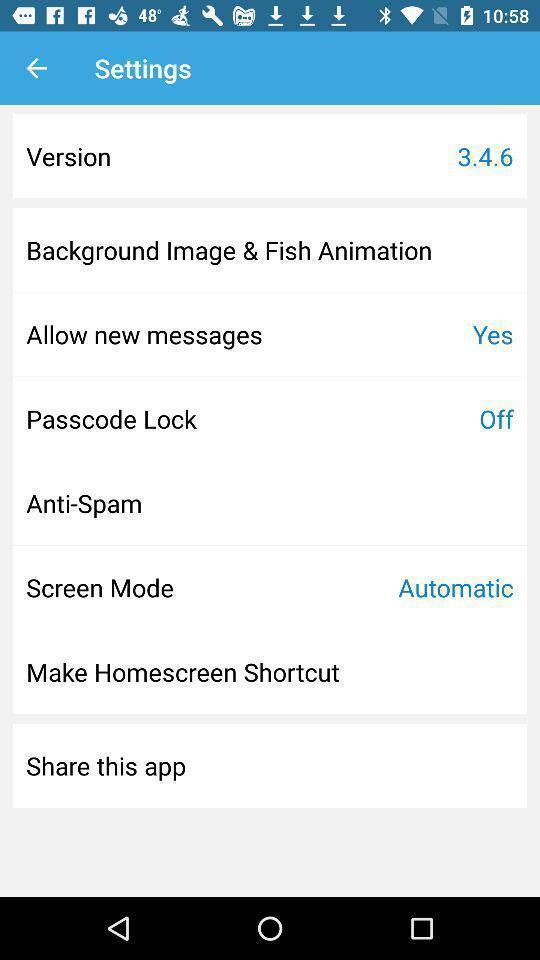Explain what's happening in this screen capture. Settings page displayed. 